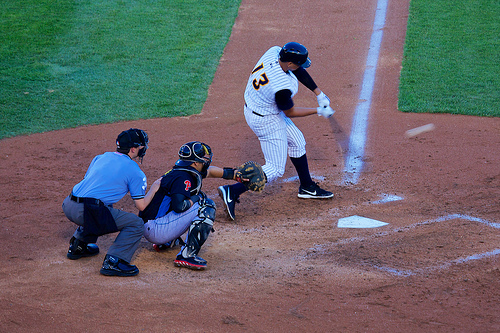What color is the shirt the umpire is wearing? The umpire's shirt is blue, typical of the attire worn to distinguish them from the players. 